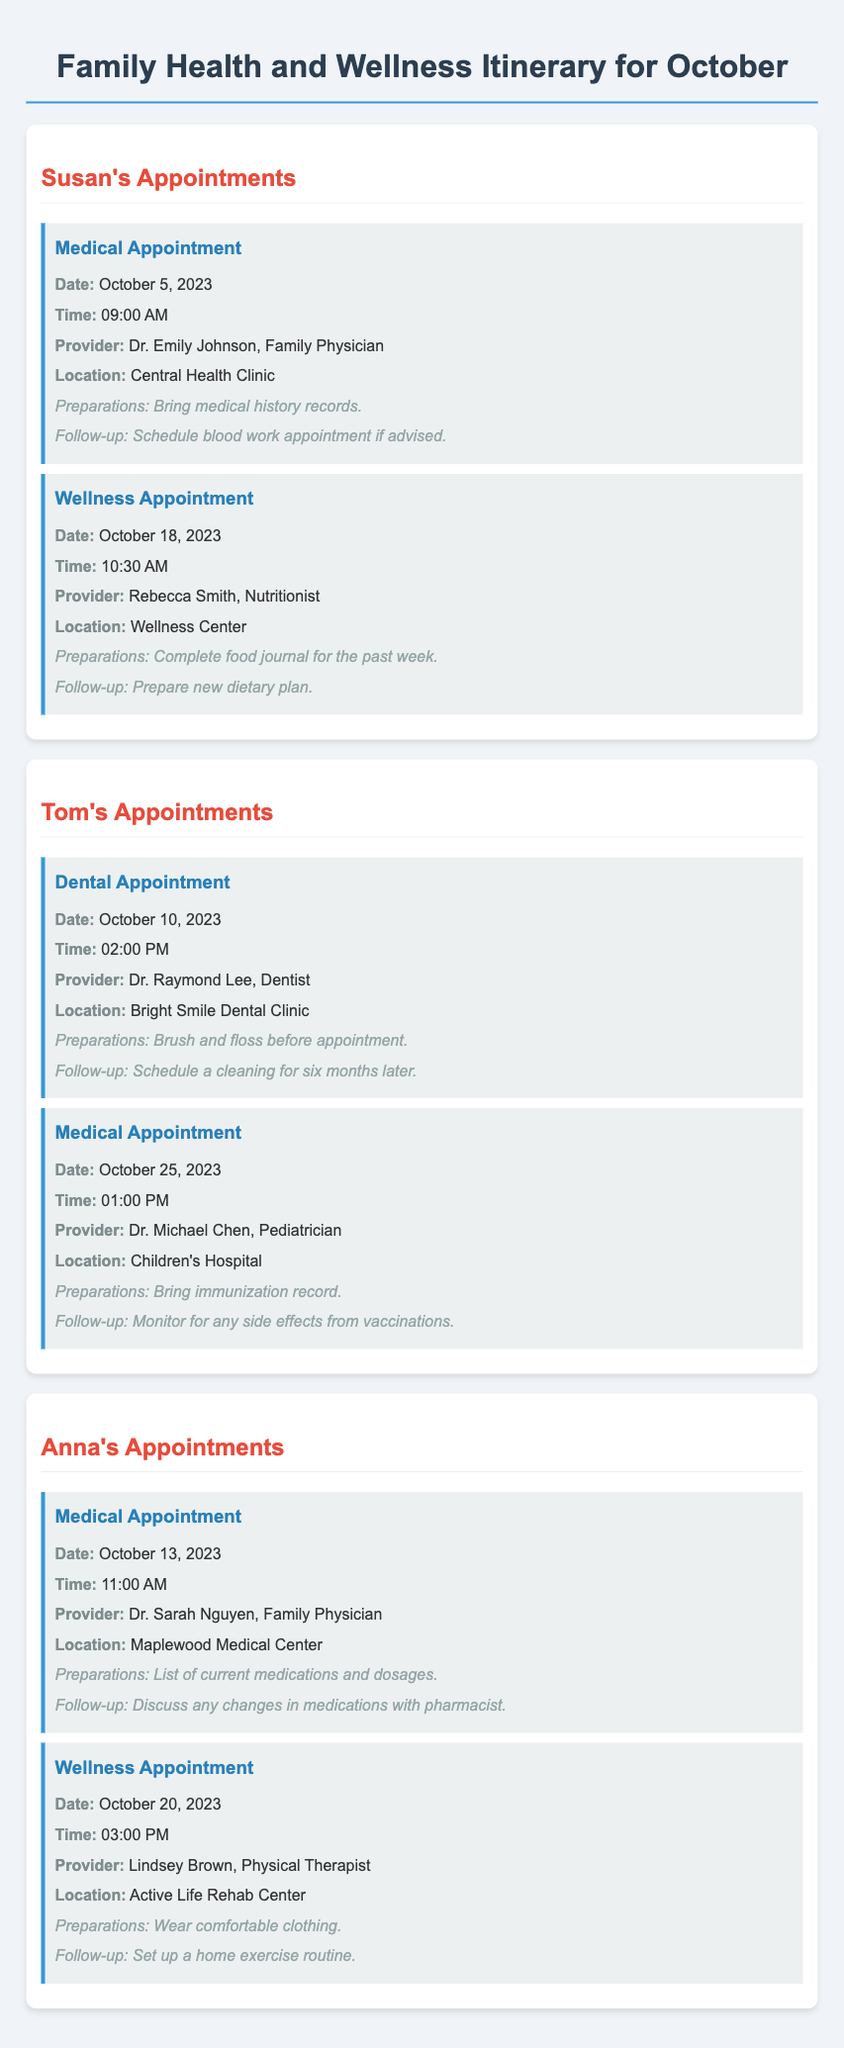What is the date of Susan's medical appointment? The date of Susan's medical appointment is given in the document.
Answer: October 5, 2023 Who is Tom's dentist? The document states the name of Tom's dentist and provides details about the appointment.
Answer: Dr. Raymond Lee What time is Anna's wellness appointment scheduled? The document specifies the time for Anna's wellness appointment.
Answer: 03:00 PM What is required for Susan's wellness appointment preparation? The document lists specific preparations needed for each appointment.
Answer: Complete food journal for the past week How many appointments does Anna have in October? The document mentions the number of appointments listed for Anna.
Answer: 2 